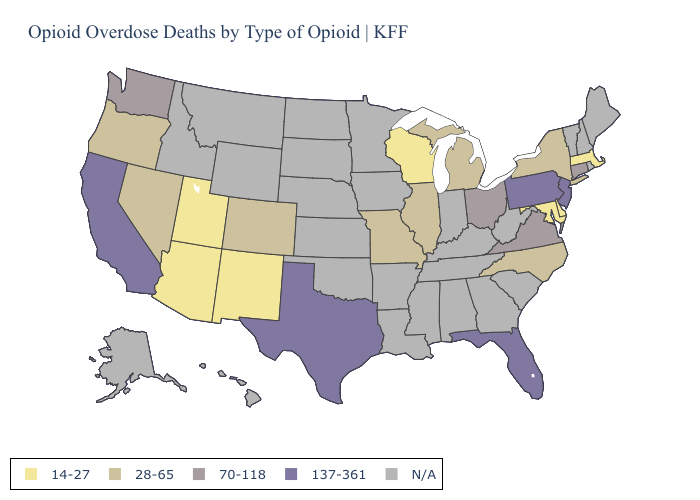What is the value of Missouri?
Concise answer only. 28-65. Name the states that have a value in the range 137-361?
Keep it brief. California, Florida, New Jersey, Pennsylvania, Texas. Name the states that have a value in the range 28-65?
Short answer required. Colorado, Illinois, Michigan, Missouri, Nevada, New York, North Carolina, Oregon. Name the states that have a value in the range 70-118?
Give a very brief answer. Connecticut, Ohio, Virginia, Washington. Which states have the highest value in the USA?
Quick response, please. California, Florida, New Jersey, Pennsylvania, Texas. What is the highest value in the MidWest ?
Write a very short answer. 70-118. What is the value of Maryland?
Quick response, please. 14-27. What is the value of Vermont?
Give a very brief answer. N/A. Does Maryland have the lowest value in the USA?
Write a very short answer. Yes. Among the states that border Rhode Island , does Connecticut have the lowest value?
Answer briefly. No. Among the states that border Wyoming , which have the lowest value?
Be succinct. Utah. Among the states that border Tennessee , which have the lowest value?
Quick response, please. Missouri, North Carolina. Is the legend a continuous bar?
Short answer required. No. Name the states that have a value in the range 70-118?
Give a very brief answer. Connecticut, Ohio, Virginia, Washington. 